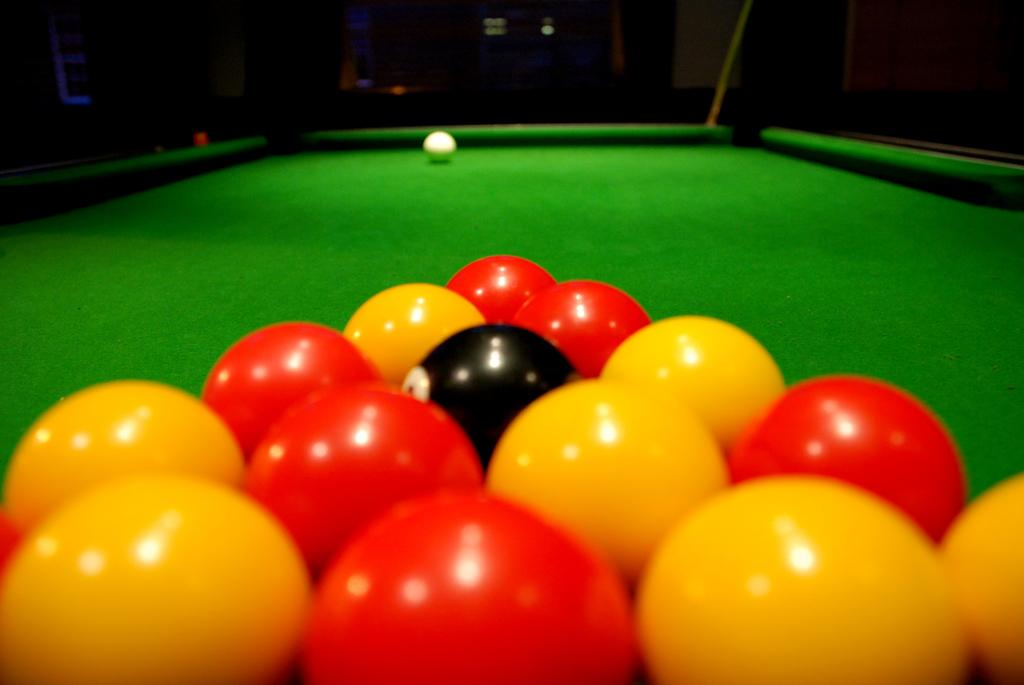What is on the snooker table in the image? There are balls on a snooker table in the image. What can be observed about the background of the image? The background of the image is dark. How many legs does the carriage have in the image? There is no carriage present in the image. 